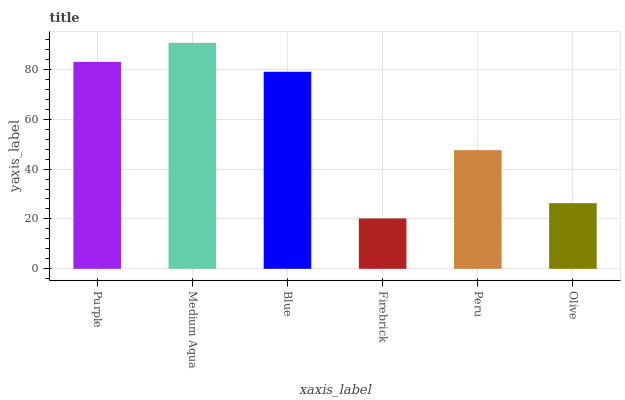Is Blue the minimum?
Answer yes or no. No. Is Blue the maximum?
Answer yes or no. No. Is Medium Aqua greater than Blue?
Answer yes or no. Yes. Is Blue less than Medium Aqua?
Answer yes or no. Yes. Is Blue greater than Medium Aqua?
Answer yes or no. No. Is Medium Aqua less than Blue?
Answer yes or no. No. Is Blue the high median?
Answer yes or no. Yes. Is Peru the low median?
Answer yes or no. Yes. Is Olive the high median?
Answer yes or no. No. Is Blue the low median?
Answer yes or no. No. 